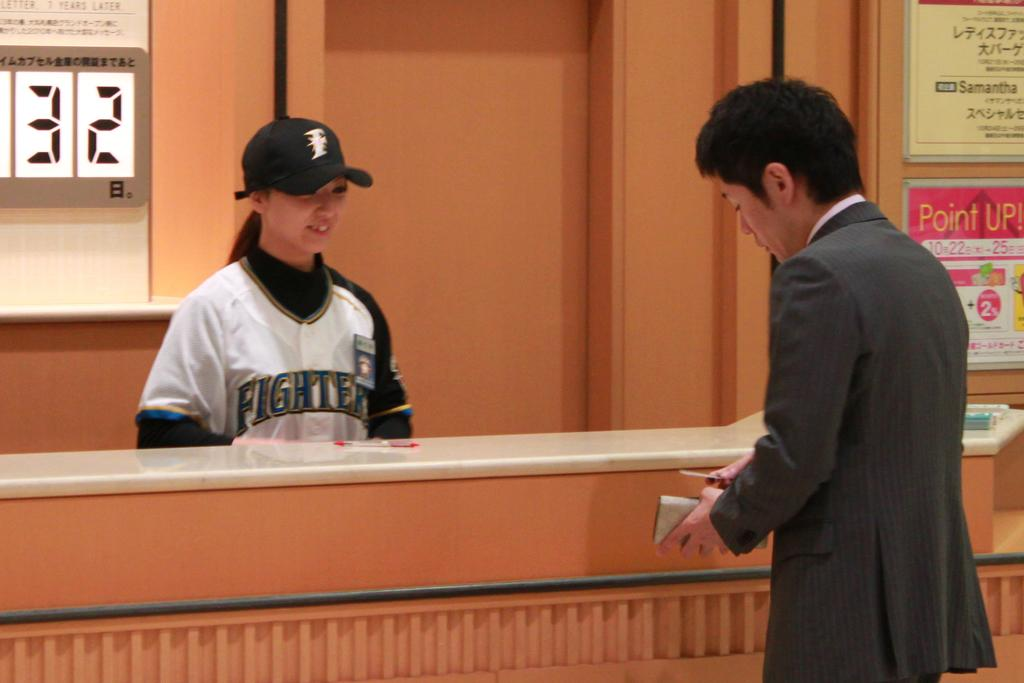Provide a one-sentence caption for the provided image. A girl wearing a fighters jersey smiling at a man. 